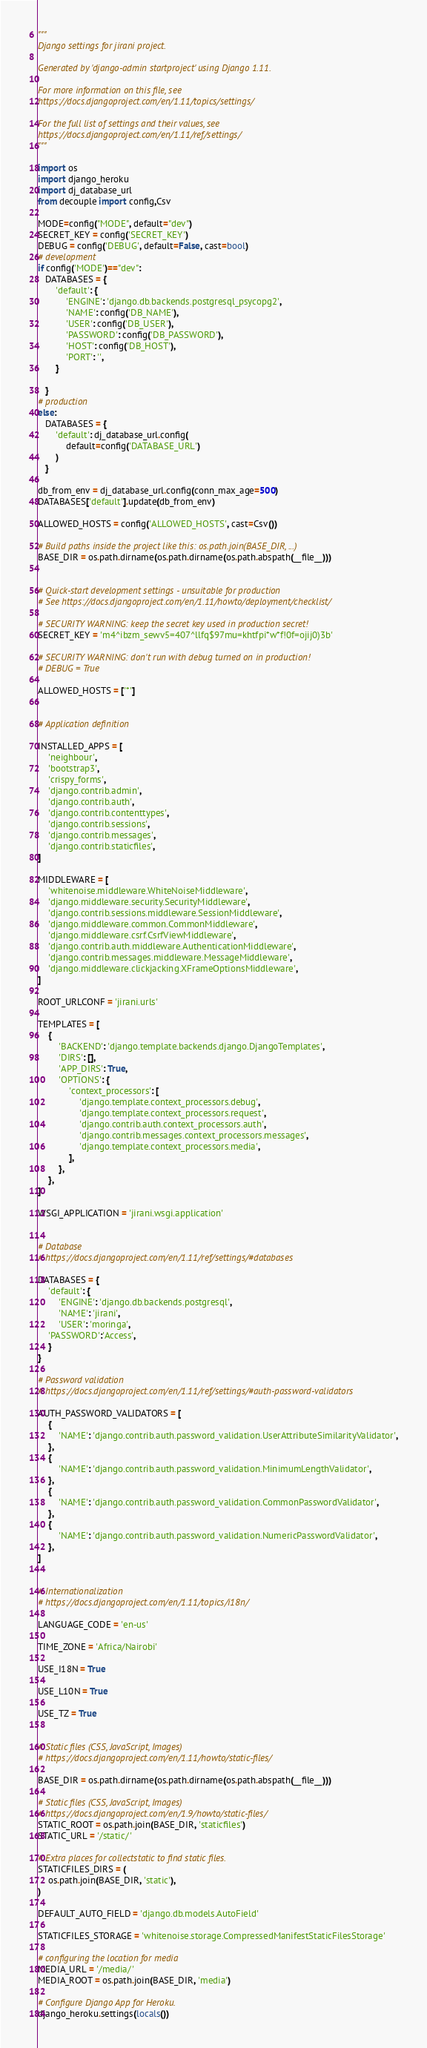<code> <loc_0><loc_0><loc_500><loc_500><_Python_>"""
Django settings for jirani project.

Generated by 'django-admin startproject' using Django 1.11.

For more information on this file, see
https://docs.djangoproject.com/en/1.11/topics/settings/

For the full list of settings and their values, see
https://docs.djangoproject.com/en/1.11/ref/settings/
"""

import os
import django_heroku
import dj_database_url
from decouple import config,Csv

MODE=config("MODE", default="dev")
SECRET_KEY = config('SECRET_KEY')
DEBUG = config('DEBUG', default=False, cast=bool)
# development
if config('MODE')=="dev":
   DATABASES = {
       'default': {
           'ENGINE': 'django.db.backends.postgresql_psycopg2',
           'NAME': config('DB_NAME'),
           'USER': config('DB_USER'),
           'PASSWORD': config('DB_PASSWORD'),
           'HOST': config('DB_HOST'),
           'PORT': '',
       }
       
   }
# production
else:
   DATABASES = {
       'default': dj_database_url.config(
           default=config('DATABASE_URL')
       )
   }

db_from_env = dj_database_url.config(conn_max_age=500)
DATABASES['default'].update(db_from_env)

ALLOWED_HOSTS = config('ALLOWED_HOSTS', cast=Csv())

# Build paths inside the project like this: os.path.join(BASE_DIR, ...)
BASE_DIR = os.path.dirname(os.path.dirname(os.path.abspath(__file__)))


# Quick-start development settings - unsuitable for production
# See https://docs.djangoproject.com/en/1.11/howto/deployment/checklist/

# SECURITY WARNING: keep the secret key used in production secret!
SECRET_KEY = 'm4^ibzm_sewv5=407^llfq$97mu=khtfpi*w*f!0f=ojij0)3b'

# SECURITY WARNING: don't run with debug turned on in production!
# DEBUG = True

ALLOWED_HOSTS = ['*']


# Application definition

INSTALLED_APPS = [
    'neighbour',
    'bootstrap3',
    'crispy_forms',
    'django.contrib.admin',
    'django.contrib.auth',
    'django.contrib.contenttypes',
    'django.contrib.sessions',
    'django.contrib.messages',
    'django.contrib.staticfiles',
]

MIDDLEWARE = [
    'whitenoise.middleware.WhiteNoiseMiddleware',
    'django.middleware.security.SecurityMiddleware',
    'django.contrib.sessions.middleware.SessionMiddleware',
    'django.middleware.common.CommonMiddleware',
    'django.middleware.csrf.CsrfViewMiddleware',
    'django.contrib.auth.middleware.AuthenticationMiddleware',
    'django.contrib.messages.middleware.MessageMiddleware',
    'django.middleware.clickjacking.XFrameOptionsMiddleware',
]

ROOT_URLCONF = 'jirani.urls'

TEMPLATES = [
    {
        'BACKEND': 'django.template.backends.django.DjangoTemplates',
        'DIRS': [],
        'APP_DIRS': True,
        'OPTIONS': {
            'context_processors': [
                'django.template.context_processors.debug',
                'django.template.context_processors.request',
                'django.contrib.auth.context_processors.auth',
                'django.contrib.messages.context_processors.messages',
                'django.template.context_processors.media',
            ],
        },
    },
]

WSGI_APPLICATION = 'jirani.wsgi.application'


# Database
# https://docs.djangoproject.com/en/1.11/ref/settings/#databases

DATABASES = {
    'default': {
        'ENGINE': 'django.db.backends.postgresql',
        'NAME': 'jirani',
        'USER': 'moringa',
    'PASSWORD':'Access',
    }
}

# Password validation
# https://docs.djangoproject.com/en/1.11/ref/settings/#auth-password-validators

AUTH_PASSWORD_VALIDATORS = [
    {
        'NAME': 'django.contrib.auth.password_validation.UserAttributeSimilarityValidator',
    },
    {
        'NAME': 'django.contrib.auth.password_validation.MinimumLengthValidator',
    },
    {
        'NAME': 'django.contrib.auth.password_validation.CommonPasswordValidator',
    },
    {
        'NAME': 'django.contrib.auth.password_validation.NumericPasswordValidator',
    },
]


# Internationalization
# https://docs.djangoproject.com/en/1.11/topics/i18n/

LANGUAGE_CODE = 'en-us'

TIME_ZONE = 'Africa/Nairobi'

USE_I18N = True

USE_L10N = True

USE_TZ = True


# Static files (CSS, JavaScript, Images)
# https://docs.djangoproject.com/en/1.11/howto/static-files/

BASE_DIR = os.path.dirname(os.path.dirname(os.path.abspath(__file__)))

# Static files (CSS, JavaScript, Images)
# https://docs.djangoproject.com/en/1.9/howto/static-files/
STATIC_ROOT = os.path.join(BASE_DIR, 'staticfiles')
STATIC_URL = '/static/'

# Extra places for collectstatic to find static files.
STATICFILES_DIRS = (
    os.path.join(BASE_DIR, 'static'),
)

DEFAULT_AUTO_FIELD = 'django.db.models.AutoField'

STATICFILES_STORAGE = 'whitenoise.storage.CompressedManifestStaticFilesStorage'

# configuring the location for media
MEDIA_URL = '/media/'
MEDIA_ROOT = os.path.join(BASE_DIR, 'media')

# Configure Django App for Heroku.
django_heroku.settings(locals())</code> 